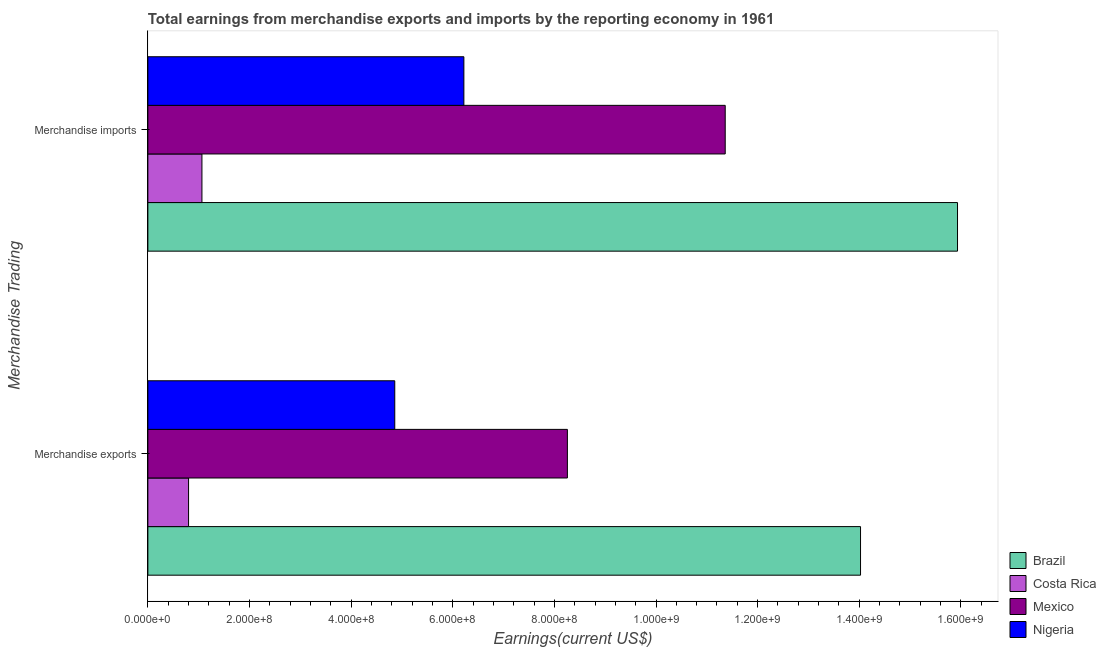Are the number of bars per tick equal to the number of legend labels?
Make the answer very short. Yes. Are the number of bars on each tick of the Y-axis equal?
Your answer should be compact. Yes. How many bars are there on the 2nd tick from the top?
Make the answer very short. 4. How many bars are there on the 2nd tick from the bottom?
Make the answer very short. 4. What is the label of the 1st group of bars from the top?
Ensure brevity in your answer.  Merchandise imports. What is the earnings from merchandise exports in Brazil?
Offer a terse response. 1.40e+09. Across all countries, what is the maximum earnings from merchandise exports?
Provide a succinct answer. 1.40e+09. Across all countries, what is the minimum earnings from merchandise imports?
Ensure brevity in your answer.  1.06e+08. In which country was the earnings from merchandise exports maximum?
Give a very brief answer. Brazil. In which country was the earnings from merchandise imports minimum?
Offer a terse response. Costa Rica. What is the total earnings from merchandise imports in the graph?
Make the answer very short. 3.46e+09. What is the difference between the earnings from merchandise exports in Brazil and that in Mexico?
Your answer should be very brief. 5.77e+08. What is the difference between the earnings from merchandise imports in Mexico and the earnings from merchandise exports in Nigeria?
Provide a succinct answer. 6.50e+08. What is the average earnings from merchandise exports per country?
Your answer should be compact. 6.99e+08. What is the difference between the earnings from merchandise exports and earnings from merchandise imports in Costa Rica?
Make the answer very short. -2.63e+07. In how many countries, is the earnings from merchandise imports greater than 480000000 US$?
Your response must be concise. 3. What is the ratio of the earnings from merchandise imports in Mexico to that in Brazil?
Offer a very short reply. 0.71. Is the earnings from merchandise imports in Brazil less than that in Costa Rica?
Ensure brevity in your answer.  No. In how many countries, is the earnings from merchandise exports greater than the average earnings from merchandise exports taken over all countries?
Your answer should be compact. 2. What does the 1st bar from the top in Merchandise exports represents?
Make the answer very short. Nigeria. How many bars are there?
Keep it short and to the point. 8. Are the values on the major ticks of X-axis written in scientific E-notation?
Your answer should be compact. Yes. Does the graph contain any zero values?
Ensure brevity in your answer.  No. How many legend labels are there?
Ensure brevity in your answer.  4. What is the title of the graph?
Your answer should be compact. Total earnings from merchandise exports and imports by the reporting economy in 1961. Does "East Asia (developing only)" appear as one of the legend labels in the graph?
Offer a terse response. No. What is the label or title of the X-axis?
Ensure brevity in your answer.  Earnings(current US$). What is the label or title of the Y-axis?
Your answer should be compact. Merchandise Trading. What is the Earnings(current US$) of Brazil in Merchandise exports?
Your response must be concise. 1.40e+09. What is the Earnings(current US$) of Costa Rica in Merchandise exports?
Offer a terse response. 8.01e+07. What is the Earnings(current US$) of Mexico in Merchandise exports?
Give a very brief answer. 8.26e+08. What is the Earnings(current US$) of Nigeria in Merchandise exports?
Make the answer very short. 4.86e+08. What is the Earnings(current US$) of Brazil in Merchandise imports?
Ensure brevity in your answer.  1.59e+09. What is the Earnings(current US$) in Costa Rica in Merchandise imports?
Ensure brevity in your answer.  1.06e+08. What is the Earnings(current US$) of Mexico in Merchandise imports?
Ensure brevity in your answer.  1.14e+09. What is the Earnings(current US$) of Nigeria in Merchandise imports?
Provide a short and direct response. 6.22e+08. Across all Merchandise Trading, what is the maximum Earnings(current US$) in Brazil?
Ensure brevity in your answer.  1.59e+09. Across all Merchandise Trading, what is the maximum Earnings(current US$) of Costa Rica?
Your answer should be compact. 1.06e+08. Across all Merchandise Trading, what is the maximum Earnings(current US$) of Mexico?
Keep it short and to the point. 1.14e+09. Across all Merchandise Trading, what is the maximum Earnings(current US$) of Nigeria?
Provide a short and direct response. 6.22e+08. Across all Merchandise Trading, what is the minimum Earnings(current US$) in Brazil?
Offer a very short reply. 1.40e+09. Across all Merchandise Trading, what is the minimum Earnings(current US$) of Costa Rica?
Give a very brief answer. 8.01e+07. Across all Merchandise Trading, what is the minimum Earnings(current US$) of Mexico?
Offer a very short reply. 8.26e+08. Across all Merchandise Trading, what is the minimum Earnings(current US$) of Nigeria?
Give a very brief answer. 4.86e+08. What is the total Earnings(current US$) of Brazil in the graph?
Keep it short and to the point. 3.00e+09. What is the total Earnings(current US$) in Costa Rica in the graph?
Keep it short and to the point. 1.86e+08. What is the total Earnings(current US$) in Mexico in the graph?
Keep it short and to the point. 1.96e+09. What is the total Earnings(current US$) of Nigeria in the graph?
Make the answer very short. 1.11e+09. What is the difference between the Earnings(current US$) of Brazil in Merchandise exports and that in Merchandise imports?
Offer a terse response. -1.91e+08. What is the difference between the Earnings(current US$) in Costa Rica in Merchandise exports and that in Merchandise imports?
Provide a short and direct response. -2.63e+07. What is the difference between the Earnings(current US$) of Mexico in Merchandise exports and that in Merchandise imports?
Your answer should be compact. -3.11e+08. What is the difference between the Earnings(current US$) of Nigeria in Merchandise exports and that in Merchandise imports?
Your response must be concise. -1.36e+08. What is the difference between the Earnings(current US$) in Brazil in Merchandise exports and the Earnings(current US$) in Costa Rica in Merchandise imports?
Ensure brevity in your answer.  1.30e+09. What is the difference between the Earnings(current US$) of Brazil in Merchandise exports and the Earnings(current US$) of Mexico in Merchandise imports?
Make the answer very short. 2.66e+08. What is the difference between the Earnings(current US$) in Brazil in Merchandise exports and the Earnings(current US$) in Nigeria in Merchandise imports?
Your answer should be very brief. 7.81e+08. What is the difference between the Earnings(current US$) of Costa Rica in Merchandise exports and the Earnings(current US$) of Mexico in Merchandise imports?
Your answer should be very brief. -1.06e+09. What is the difference between the Earnings(current US$) in Costa Rica in Merchandise exports and the Earnings(current US$) in Nigeria in Merchandise imports?
Keep it short and to the point. -5.42e+08. What is the difference between the Earnings(current US$) in Mexico in Merchandise exports and the Earnings(current US$) in Nigeria in Merchandise imports?
Your response must be concise. 2.04e+08. What is the average Earnings(current US$) of Brazil per Merchandise Trading?
Your answer should be very brief. 1.50e+09. What is the average Earnings(current US$) in Costa Rica per Merchandise Trading?
Provide a succinct answer. 9.32e+07. What is the average Earnings(current US$) of Mexico per Merchandise Trading?
Keep it short and to the point. 9.81e+08. What is the average Earnings(current US$) of Nigeria per Merchandise Trading?
Make the answer very short. 5.54e+08. What is the difference between the Earnings(current US$) of Brazil and Earnings(current US$) of Costa Rica in Merchandise exports?
Your answer should be compact. 1.32e+09. What is the difference between the Earnings(current US$) in Brazil and Earnings(current US$) in Mexico in Merchandise exports?
Make the answer very short. 5.77e+08. What is the difference between the Earnings(current US$) of Brazil and Earnings(current US$) of Nigeria in Merchandise exports?
Make the answer very short. 9.17e+08. What is the difference between the Earnings(current US$) in Costa Rica and Earnings(current US$) in Mexico in Merchandise exports?
Make the answer very short. -7.46e+08. What is the difference between the Earnings(current US$) of Costa Rica and Earnings(current US$) of Nigeria in Merchandise exports?
Provide a succinct answer. -4.06e+08. What is the difference between the Earnings(current US$) of Mexico and Earnings(current US$) of Nigeria in Merchandise exports?
Your response must be concise. 3.40e+08. What is the difference between the Earnings(current US$) in Brazil and Earnings(current US$) in Costa Rica in Merchandise imports?
Provide a succinct answer. 1.49e+09. What is the difference between the Earnings(current US$) in Brazil and Earnings(current US$) in Mexico in Merchandise imports?
Make the answer very short. 4.57e+08. What is the difference between the Earnings(current US$) of Brazil and Earnings(current US$) of Nigeria in Merchandise imports?
Ensure brevity in your answer.  9.71e+08. What is the difference between the Earnings(current US$) of Costa Rica and Earnings(current US$) of Mexico in Merchandise imports?
Make the answer very short. -1.03e+09. What is the difference between the Earnings(current US$) of Costa Rica and Earnings(current US$) of Nigeria in Merchandise imports?
Offer a very short reply. -5.16e+08. What is the difference between the Earnings(current US$) of Mexico and Earnings(current US$) of Nigeria in Merchandise imports?
Offer a very short reply. 5.14e+08. What is the ratio of the Earnings(current US$) in Brazil in Merchandise exports to that in Merchandise imports?
Make the answer very short. 0.88. What is the ratio of the Earnings(current US$) of Costa Rica in Merchandise exports to that in Merchandise imports?
Give a very brief answer. 0.75. What is the ratio of the Earnings(current US$) in Mexico in Merchandise exports to that in Merchandise imports?
Ensure brevity in your answer.  0.73. What is the ratio of the Earnings(current US$) of Nigeria in Merchandise exports to that in Merchandise imports?
Keep it short and to the point. 0.78. What is the difference between the highest and the second highest Earnings(current US$) of Brazil?
Provide a short and direct response. 1.91e+08. What is the difference between the highest and the second highest Earnings(current US$) in Costa Rica?
Your answer should be compact. 2.63e+07. What is the difference between the highest and the second highest Earnings(current US$) of Mexico?
Your response must be concise. 3.11e+08. What is the difference between the highest and the second highest Earnings(current US$) of Nigeria?
Give a very brief answer. 1.36e+08. What is the difference between the highest and the lowest Earnings(current US$) of Brazil?
Make the answer very short. 1.91e+08. What is the difference between the highest and the lowest Earnings(current US$) in Costa Rica?
Keep it short and to the point. 2.63e+07. What is the difference between the highest and the lowest Earnings(current US$) in Mexico?
Offer a very short reply. 3.11e+08. What is the difference between the highest and the lowest Earnings(current US$) of Nigeria?
Your response must be concise. 1.36e+08. 